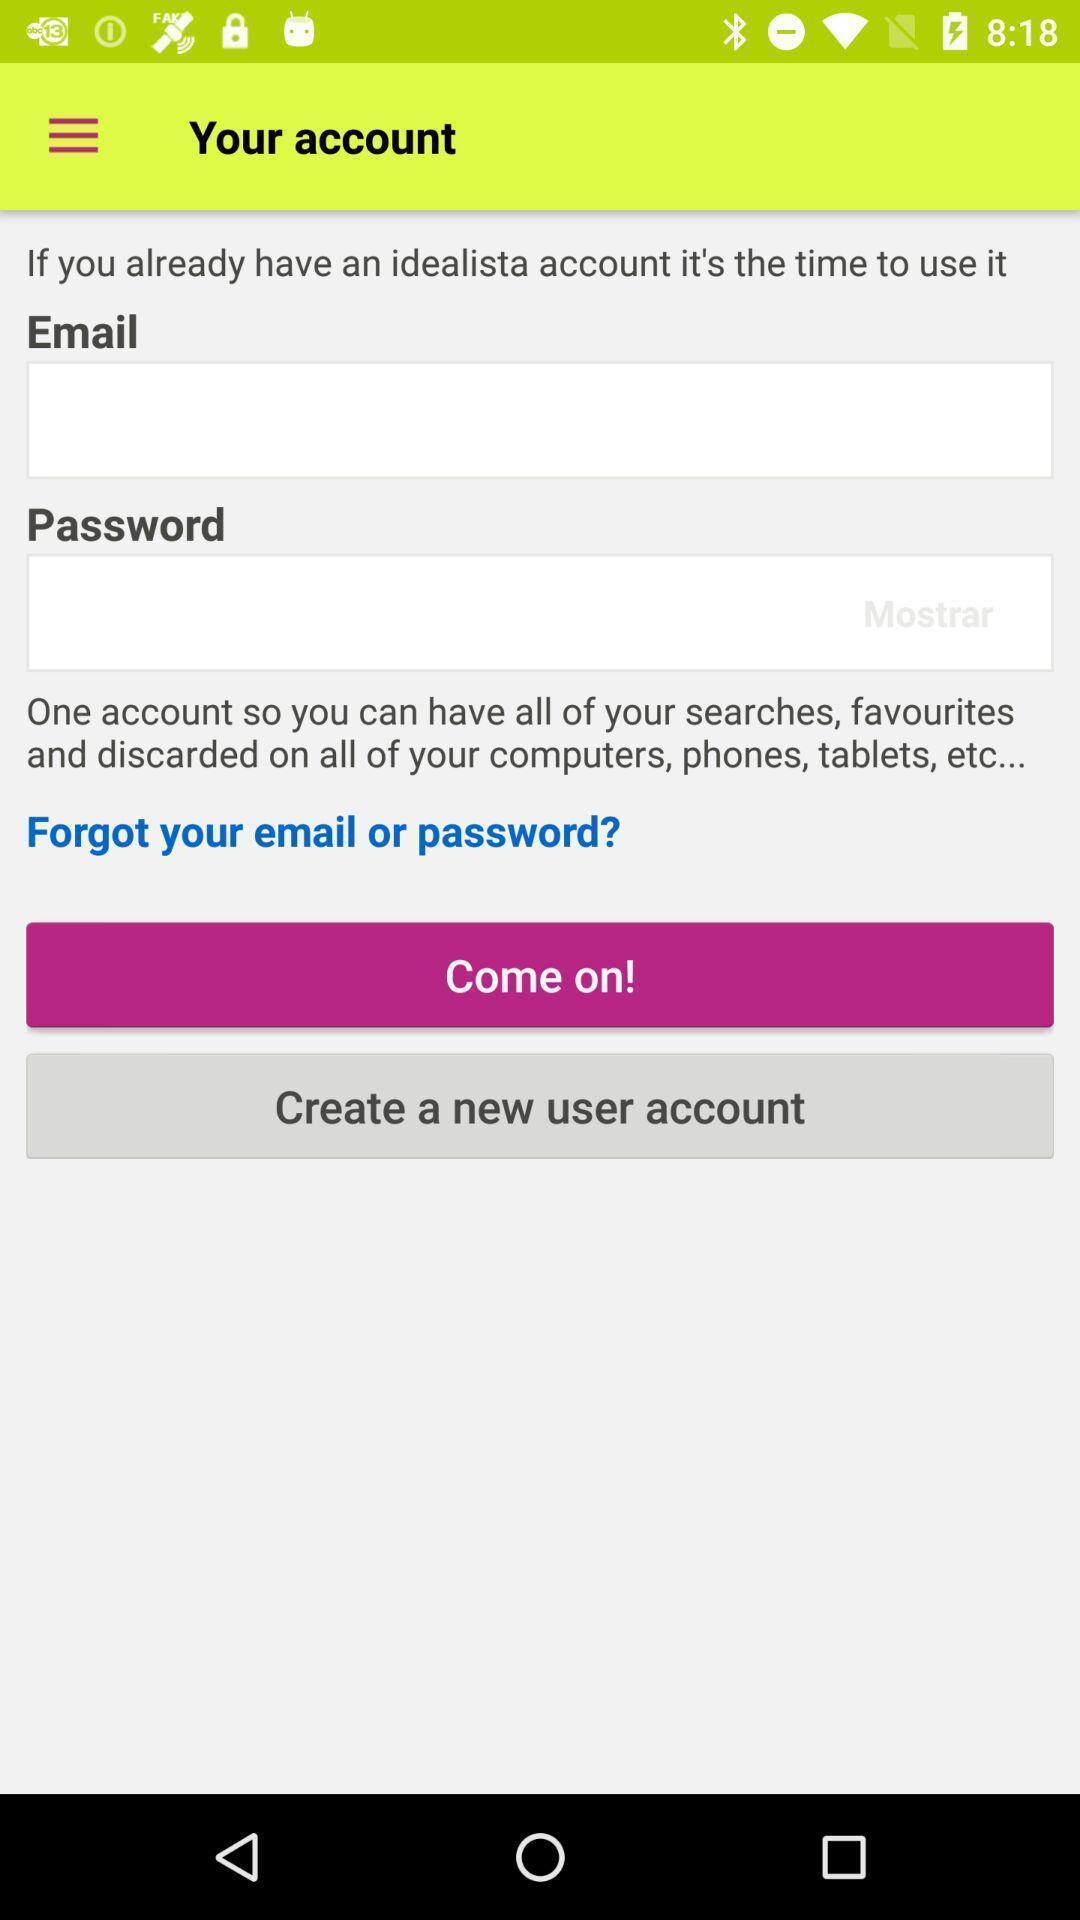Provide a textual representation of this image. Sign in page. 